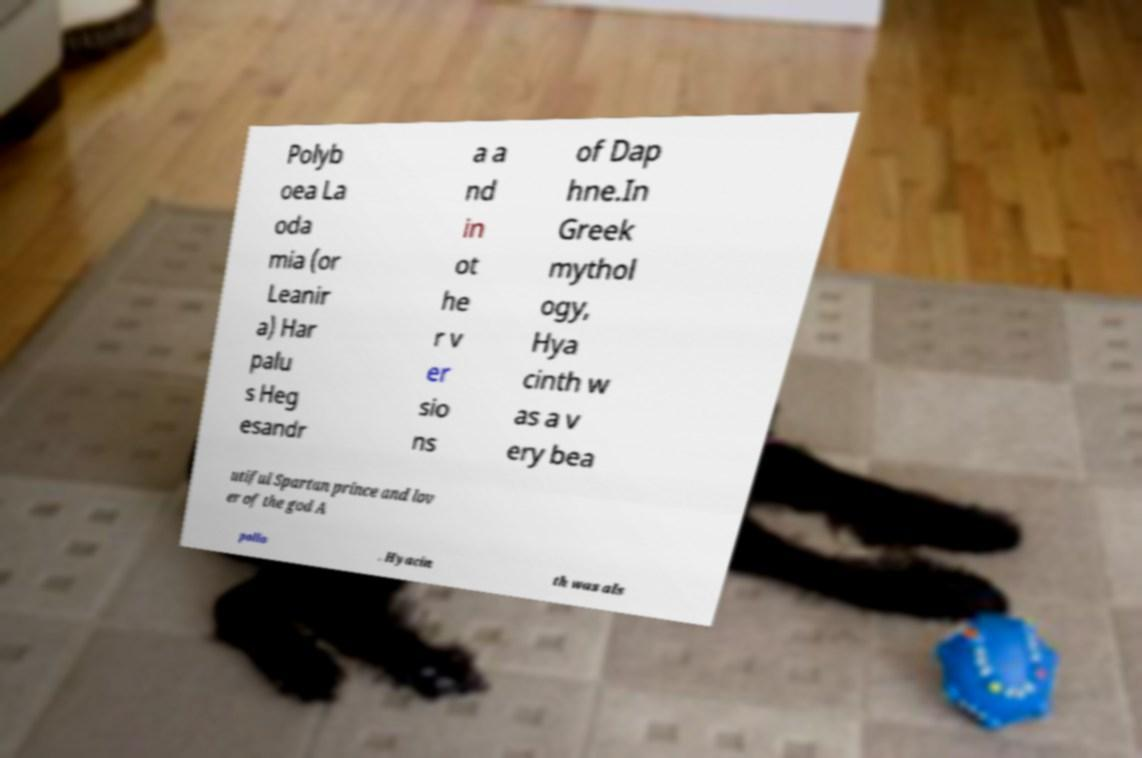Can you read and provide the text displayed in the image?This photo seems to have some interesting text. Can you extract and type it out for me? Polyb oea La oda mia (or Leanir a) Har palu s Heg esandr a a nd in ot he r v er sio ns of Dap hne.In Greek mythol ogy, Hya cinth w as a v ery bea utiful Spartan prince and lov er of the god A pollo . Hyacin th was als 